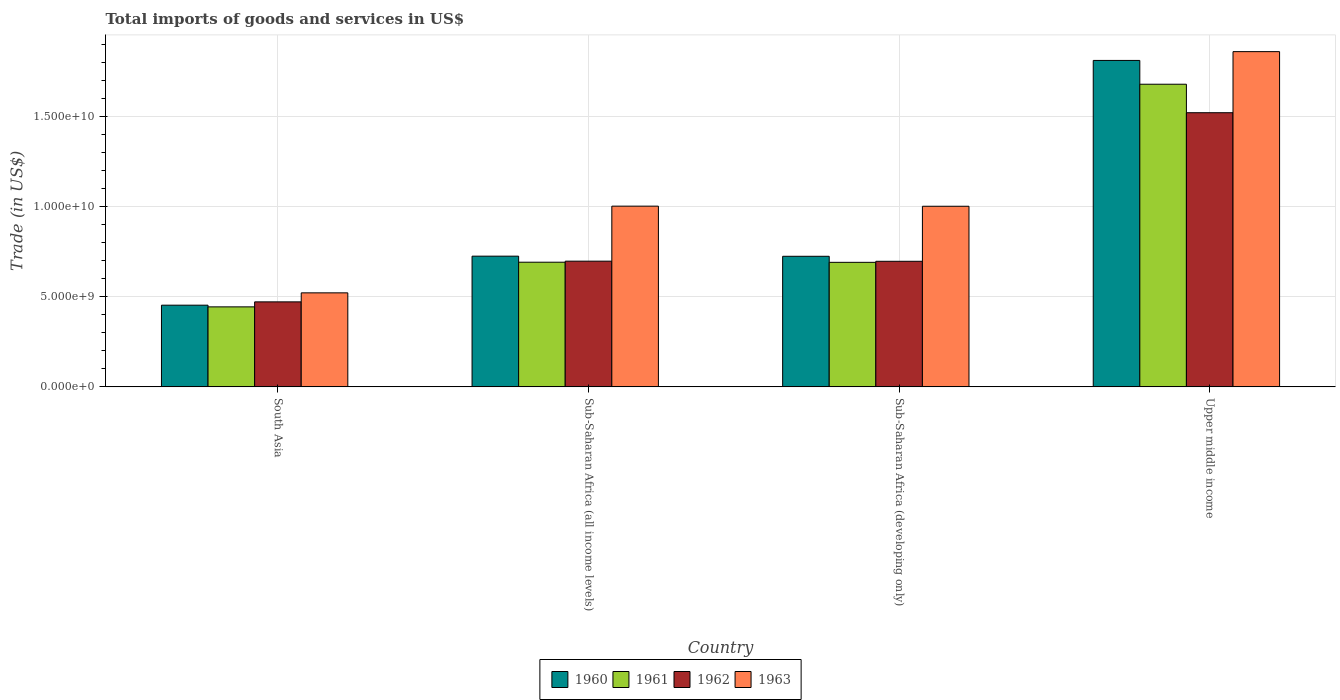How many different coloured bars are there?
Make the answer very short. 4. How many groups of bars are there?
Offer a terse response. 4. How many bars are there on the 4th tick from the left?
Offer a very short reply. 4. What is the label of the 2nd group of bars from the left?
Your response must be concise. Sub-Saharan Africa (all income levels). In how many cases, is the number of bars for a given country not equal to the number of legend labels?
Offer a terse response. 0. What is the total imports of goods and services in 1961 in South Asia?
Offer a very short reply. 4.43e+09. Across all countries, what is the maximum total imports of goods and services in 1962?
Keep it short and to the point. 1.52e+1. Across all countries, what is the minimum total imports of goods and services in 1961?
Your response must be concise. 4.43e+09. In which country was the total imports of goods and services in 1961 maximum?
Make the answer very short. Upper middle income. In which country was the total imports of goods and services in 1961 minimum?
Your answer should be very brief. South Asia. What is the total total imports of goods and services in 1963 in the graph?
Your answer should be compact. 4.38e+1. What is the difference between the total imports of goods and services in 1962 in South Asia and that in Sub-Saharan Africa (all income levels)?
Provide a short and direct response. -2.26e+09. What is the difference between the total imports of goods and services in 1960 in Sub-Saharan Africa (all income levels) and the total imports of goods and services in 1962 in Sub-Saharan Africa (developing only)?
Provide a succinct answer. 2.84e+08. What is the average total imports of goods and services in 1963 per country?
Make the answer very short. 1.10e+1. What is the difference between the total imports of goods and services of/in 1963 and total imports of goods and services of/in 1960 in South Asia?
Offer a terse response. 6.84e+08. What is the ratio of the total imports of goods and services in 1960 in South Asia to that in Upper middle income?
Give a very brief answer. 0.25. Is the difference between the total imports of goods and services in 1963 in South Asia and Sub-Saharan Africa (all income levels) greater than the difference between the total imports of goods and services in 1960 in South Asia and Sub-Saharan Africa (all income levels)?
Your answer should be very brief. No. What is the difference between the highest and the second highest total imports of goods and services in 1962?
Ensure brevity in your answer.  -8.23e+09. What is the difference between the highest and the lowest total imports of goods and services in 1962?
Make the answer very short. 1.05e+1. In how many countries, is the total imports of goods and services in 1963 greater than the average total imports of goods and services in 1963 taken over all countries?
Offer a terse response. 1. Is the sum of the total imports of goods and services in 1960 in Sub-Saharan Africa (all income levels) and Sub-Saharan Africa (developing only) greater than the maximum total imports of goods and services in 1963 across all countries?
Provide a succinct answer. No. Is it the case that in every country, the sum of the total imports of goods and services in 1960 and total imports of goods and services in 1963 is greater than the sum of total imports of goods and services in 1961 and total imports of goods and services in 1962?
Make the answer very short. No. What does the 4th bar from the left in Upper middle income represents?
Make the answer very short. 1963. What does the 2nd bar from the right in Sub-Saharan Africa (developing only) represents?
Offer a terse response. 1962. How many countries are there in the graph?
Your answer should be compact. 4. Are the values on the major ticks of Y-axis written in scientific E-notation?
Make the answer very short. Yes. Where does the legend appear in the graph?
Offer a terse response. Bottom center. How are the legend labels stacked?
Make the answer very short. Horizontal. What is the title of the graph?
Give a very brief answer. Total imports of goods and services in US$. What is the label or title of the X-axis?
Offer a very short reply. Country. What is the label or title of the Y-axis?
Your answer should be compact. Trade (in US$). What is the Trade (in US$) in 1960 in South Asia?
Offer a terse response. 4.53e+09. What is the Trade (in US$) of 1961 in South Asia?
Your answer should be compact. 4.43e+09. What is the Trade (in US$) in 1962 in South Asia?
Provide a short and direct response. 4.71e+09. What is the Trade (in US$) of 1963 in South Asia?
Your answer should be very brief. 5.21e+09. What is the Trade (in US$) of 1960 in Sub-Saharan Africa (all income levels)?
Your answer should be compact. 7.25e+09. What is the Trade (in US$) of 1961 in Sub-Saharan Africa (all income levels)?
Your answer should be compact. 6.91e+09. What is the Trade (in US$) of 1962 in Sub-Saharan Africa (all income levels)?
Make the answer very short. 6.97e+09. What is the Trade (in US$) in 1963 in Sub-Saharan Africa (all income levels)?
Provide a succinct answer. 1.00e+1. What is the Trade (in US$) of 1960 in Sub-Saharan Africa (developing only)?
Provide a short and direct response. 7.24e+09. What is the Trade (in US$) in 1961 in Sub-Saharan Africa (developing only)?
Your answer should be very brief. 6.90e+09. What is the Trade (in US$) of 1962 in Sub-Saharan Africa (developing only)?
Offer a terse response. 6.96e+09. What is the Trade (in US$) in 1963 in Sub-Saharan Africa (developing only)?
Make the answer very short. 1.00e+1. What is the Trade (in US$) of 1960 in Upper middle income?
Provide a succinct answer. 1.81e+1. What is the Trade (in US$) in 1961 in Upper middle income?
Keep it short and to the point. 1.68e+1. What is the Trade (in US$) in 1962 in Upper middle income?
Provide a short and direct response. 1.52e+1. What is the Trade (in US$) in 1963 in Upper middle income?
Offer a terse response. 1.86e+1. Across all countries, what is the maximum Trade (in US$) in 1960?
Your answer should be compact. 1.81e+1. Across all countries, what is the maximum Trade (in US$) in 1961?
Offer a very short reply. 1.68e+1. Across all countries, what is the maximum Trade (in US$) in 1962?
Give a very brief answer. 1.52e+1. Across all countries, what is the maximum Trade (in US$) in 1963?
Keep it short and to the point. 1.86e+1. Across all countries, what is the minimum Trade (in US$) of 1960?
Provide a succinct answer. 4.53e+09. Across all countries, what is the minimum Trade (in US$) in 1961?
Offer a very short reply. 4.43e+09. Across all countries, what is the minimum Trade (in US$) in 1962?
Provide a succinct answer. 4.71e+09. Across all countries, what is the minimum Trade (in US$) in 1963?
Your answer should be compact. 5.21e+09. What is the total Trade (in US$) in 1960 in the graph?
Your answer should be very brief. 3.71e+1. What is the total Trade (in US$) of 1961 in the graph?
Your answer should be very brief. 3.50e+1. What is the total Trade (in US$) of 1962 in the graph?
Your answer should be compact. 3.38e+1. What is the total Trade (in US$) of 1963 in the graph?
Ensure brevity in your answer.  4.38e+1. What is the difference between the Trade (in US$) in 1960 in South Asia and that in Sub-Saharan Africa (all income levels)?
Your answer should be compact. -2.72e+09. What is the difference between the Trade (in US$) in 1961 in South Asia and that in Sub-Saharan Africa (all income levels)?
Keep it short and to the point. -2.47e+09. What is the difference between the Trade (in US$) in 1962 in South Asia and that in Sub-Saharan Africa (all income levels)?
Make the answer very short. -2.26e+09. What is the difference between the Trade (in US$) in 1963 in South Asia and that in Sub-Saharan Africa (all income levels)?
Your response must be concise. -4.81e+09. What is the difference between the Trade (in US$) of 1960 in South Asia and that in Sub-Saharan Africa (developing only)?
Make the answer very short. -2.71e+09. What is the difference between the Trade (in US$) in 1961 in South Asia and that in Sub-Saharan Africa (developing only)?
Your answer should be very brief. -2.47e+09. What is the difference between the Trade (in US$) of 1962 in South Asia and that in Sub-Saharan Africa (developing only)?
Your answer should be compact. -2.25e+09. What is the difference between the Trade (in US$) of 1963 in South Asia and that in Sub-Saharan Africa (developing only)?
Your response must be concise. -4.80e+09. What is the difference between the Trade (in US$) in 1960 in South Asia and that in Upper middle income?
Ensure brevity in your answer.  -1.36e+1. What is the difference between the Trade (in US$) of 1961 in South Asia and that in Upper middle income?
Your answer should be very brief. -1.23e+1. What is the difference between the Trade (in US$) of 1962 in South Asia and that in Upper middle income?
Give a very brief answer. -1.05e+1. What is the difference between the Trade (in US$) of 1963 in South Asia and that in Upper middle income?
Give a very brief answer. -1.34e+1. What is the difference between the Trade (in US$) of 1960 in Sub-Saharan Africa (all income levels) and that in Sub-Saharan Africa (developing only)?
Give a very brief answer. 6.98e+06. What is the difference between the Trade (in US$) in 1961 in Sub-Saharan Africa (all income levels) and that in Sub-Saharan Africa (developing only)?
Give a very brief answer. 6.66e+06. What is the difference between the Trade (in US$) in 1962 in Sub-Saharan Africa (all income levels) and that in Sub-Saharan Africa (developing only)?
Make the answer very short. 6.72e+06. What is the difference between the Trade (in US$) in 1963 in Sub-Saharan Africa (all income levels) and that in Sub-Saharan Africa (developing only)?
Provide a succinct answer. 5.66e+06. What is the difference between the Trade (in US$) of 1960 in Sub-Saharan Africa (all income levels) and that in Upper middle income?
Give a very brief answer. -1.08e+1. What is the difference between the Trade (in US$) of 1961 in Sub-Saharan Africa (all income levels) and that in Upper middle income?
Make the answer very short. -9.87e+09. What is the difference between the Trade (in US$) of 1962 in Sub-Saharan Africa (all income levels) and that in Upper middle income?
Ensure brevity in your answer.  -8.23e+09. What is the difference between the Trade (in US$) in 1963 in Sub-Saharan Africa (all income levels) and that in Upper middle income?
Ensure brevity in your answer.  -8.56e+09. What is the difference between the Trade (in US$) in 1960 in Sub-Saharan Africa (developing only) and that in Upper middle income?
Make the answer very short. -1.09e+1. What is the difference between the Trade (in US$) of 1961 in Sub-Saharan Africa (developing only) and that in Upper middle income?
Your answer should be very brief. -9.87e+09. What is the difference between the Trade (in US$) of 1962 in Sub-Saharan Africa (developing only) and that in Upper middle income?
Your response must be concise. -8.24e+09. What is the difference between the Trade (in US$) of 1963 in Sub-Saharan Africa (developing only) and that in Upper middle income?
Your answer should be very brief. -8.57e+09. What is the difference between the Trade (in US$) in 1960 in South Asia and the Trade (in US$) in 1961 in Sub-Saharan Africa (all income levels)?
Your answer should be very brief. -2.38e+09. What is the difference between the Trade (in US$) of 1960 in South Asia and the Trade (in US$) of 1962 in Sub-Saharan Africa (all income levels)?
Provide a short and direct response. -2.44e+09. What is the difference between the Trade (in US$) in 1960 in South Asia and the Trade (in US$) in 1963 in Sub-Saharan Africa (all income levels)?
Provide a succinct answer. -5.49e+09. What is the difference between the Trade (in US$) in 1961 in South Asia and the Trade (in US$) in 1962 in Sub-Saharan Africa (all income levels)?
Ensure brevity in your answer.  -2.53e+09. What is the difference between the Trade (in US$) in 1961 in South Asia and the Trade (in US$) in 1963 in Sub-Saharan Africa (all income levels)?
Keep it short and to the point. -5.58e+09. What is the difference between the Trade (in US$) in 1962 in South Asia and the Trade (in US$) in 1963 in Sub-Saharan Africa (all income levels)?
Ensure brevity in your answer.  -5.31e+09. What is the difference between the Trade (in US$) of 1960 in South Asia and the Trade (in US$) of 1961 in Sub-Saharan Africa (developing only)?
Ensure brevity in your answer.  -2.38e+09. What is the difference between the Trade (in US$) in 1960 in South Asia and the Trade (in US$) in 1962 in Sub-Saharan Africa (developing only)?
Keep it short and to the point. -2.43e+09. What is the difference between the Trade (in US$) in 1960 in South Asia and the Trade (in US$) in 1963 in Sub-Saharan Africa (developing only)?
Your response must be concise. -5.48e+09. What is the difference between the Trade (in US$) in 1961 in South Asia and the Trade (in US$) in 1962 in Sub-Saharan Africa (developing only)?
Make the answer very short. -2.53e+09. What is the difference between the Trade (in US$) in 1961 in South Asia and the Trade (in US$) in 1963 in Sub-Saharan Africa (developing only)?
Offer a terse response. -5.58e+09. What is the difference between the Trade (in US$) in 1962 in South Asia and the Trade (in US$) in 1963 in Sub-Saharan Africa (developing only)?
Your answer should be compact. -5.30e+09. What is the difference between the Trade (in US$) of 1960 in South Asia and the Trade (in US$) of 1961 in Upper middle income?
Your response must be concise. -1.22e+1. What is the difference between the Trade (in US$) in 1960 in South Asia and the Trade (in US$) in 1962 in Upper middle income?
Ensure brevity in your answer.  -1.07e+1. What is the difference between the Trade (in US$) of 1960 in South Asia and the Trade (in US$) of 1963 in Upper middle income?
Give a very brief answer. -1.41e+1. What is the difference between the Trade (in US$) in 1961 in South Asia and the Trade (in US$) in 1962 in Upper middle income?
Your response must be concise. -1.08e+1. What is the difference between the Trade (in US$) in 1961 in South Asia and the Trade (in US$) in 1963 in Upper middle income?
Your answer should be compact. -1.41e+1. What is the difference between the Trade (in US$) in 1962 in South Asia and the Trade (in US$) in 1963 in Upper middle income?
Your response must be concise. -1.39e+1. What is the difference between the Trade (in US$) of 1960 in Sub-Saharan Africa (all income levels) and the Trade (in US$) of 1961 in Sub-Saharan Africa (developing only)?
Your response must be concise. 3.42e+08. What is the difference between the Trade (in US$) of 1960 in Sub-Saharan Africa (all income levels) and the Trade (in US$) of 1962 in Sub-Saharan Africa (developing only)?
Provide a short and direct response. 2.84e+08. What is the difference between the Trade (in US$) of 1960 in Sub-Saharan Africa (all income levels) and the Trade (in US$) of 1963 in Sub-Saharan Africa (developing only)?
Provide a succinct answer. -2.77e+09. What is the difference between the Trade (in US$) of 1961 in Sub-Saharan Africa (all income levels) and the Trade (in US$) of 1962 in Sub-Saharan Africa (developing only)?
Keep it short and to the point. -5.13e+07. What is the difference between the Trade (in US$) in 1961 in Sub-Saharan Africa (all income levels) and the Trade (in US$) in 1963 in Sub-Saharan Africa (developing only)?
Ensure brevity in your answer.  -3.10e+09. What is the difference between the Trade (in US$) in 1962 in Sub-Saharan Africa (all income levels) and the Trade (in US$) in 1963 in Sub-Saharan Africa (developing only)?
Offer a very short reply. -3.04e+09. What is the difference between the Trade (in US$) of 1960 in Sub-Saharan Africa (all income levels) and the Trade (in US$) of 1961 in Upper middle income?
Offer a very short reply. -9.53e+09. What is the difference between the Trade (in US$) of 1960 in Sub-Saharan Africa (all income levels) and the Trade (in US$) of 1962 in Upper middle income?
Give a very brief answer. -7.95e+09. What is the difference between the Trade (in US$) of 1960 in Sub-Saharan Africa (all income levels) and the Trade (in US$) of 1963 in Upper middle income?
Provide a short and direct response. -1.13e+1. What is the difference between the Trade (in US$) in 1961 in Sub-Saharan Africa (all income levels) and the Trade (in US$) in 1962 in Upper middle income?
Your answer should be compact. -8.29e+09. What is the difference between the Trade (in US$) of 1961 in Sub-Saharan Africa (all income levels) and the Trade (in US$) of 1963 in Upper middle income?
Offer a terse response. -1.17e+1. What is the difference between the Trade (in US$) of 1962 in Sub-Saharan Africa (all income levels) and the Trade (in US$) of 1963 in Upper middle income?
Ensure brevity in your answer.  -1.16e+1. What is the difference between the Trade (in US$) of 1960 in Sub-Saharan Africa (developing only) and the Trade (in US$) of 1961 in Upper middle income?
Offer a terse response. -9.54e+09. What is the difference between the Trade (in US$) in 1960 in Sub-Saharan Africa (developing only) and the Trade (in US$) in 1962 in Upper middle income?
Offer a very short reply. -7.96e+09. What is the difference between the Trade (in US$) in 1960 in Sub-Saharan Africa (developing only) and the Trade (in US$) in 1963 in Upper middle income?
Provide a succinct answer. -1.13e+1. What is the difference between the Trade (in US$) of 1961 in Sub-Saharan Africa (developing only) and the Trade (in US$) of 1962 in Upper middle income?
Make the answer very short. -8.29e+09. What is the difference between the Trade (in US$) in 1961 in Sub-Saharan Africa (developing only) and the Trade (in US$) in 1963 in Upper middle income?
Your answer should be very brief. -1.17e+1. What is the difference between the Trade (in US$) in 1962 in Sub-Saharan Africa (developing only) and the Trade (in US$) in 1963 in Upper middle income?
Offer a very short reply. -1.16e+1. What is the average Trade (in US$) of 1960 per country?
Ensure brevity in your answer.  9.28e+09. What is the average Trade (in US$) of 1961 per country?
Your answer should be very brief. 8.76e+09. What is the average Trade (in US$) of 1962 per country?
Your response must be concise. 8.46e+09. What is the average Trade (in US$) of 1963 per country?
Provide a short and direct response. 1.10e+1. What is the difference between the Trade (in US$) in 1960 and Trade (in US$) in 1961 in South Asia?
Provide a short and direct response. 9.31e+07. What is the difference between the Trade (in US$) in 1960 and Trade (in US$) in 1962 in South Asia?
Ensure brevity in your answer.  -1.84e+08. What is the difference between the Trade (in US$) in 1960 and Trade (in US$) in 1963 in South Asia?
Your answer should be very brief. -6.84e+08. What is the difference between the Trade (in US$) in 1961 and Trade (in US$) in 1962 in South Asia?
Offer a very short reply. -2.77e+08. What is the difference between the Trade (in US$) in 1961 and Trade (in US$) in 1963 in South Asia?
Make the answer very short. -7.77e+08. What is the difference between the Trade (in US$) in 1962 and Trade (in US$) in 1963 in South Asia?
Make the answer very short. -5.00e+08. What is the difference between the Trade (in US$) of 1960 and Trade (in US$) of 1961 in Sub-Saharan Africa (all income levels)?
Give a very brief answer. 3.36e+08. What is the difference between the Trade (in US$) of 1960 and Trade (in US$) of 1962 in Sub-Saharan Africa (all income levels)?
Your response must be concise. 2.78e+08. What is the difference between the Trade (in US$) of 1960 and Trade (in US$) of 1963 in Sub-Saharan Africa (all income levels)?
Your answer should be very brief. -2.77e+09. What is the difference between the Trade (in US$) of 1961 and Trade (in US$) of 1962 in Sub-Saharan Africa (all income levels)?
Give a very brief answer. -5.80e+07. What is the difference between the Trade (in US$) in 1961 and Trade (in US$) in 1963 in Sub-Saharan Africa (all income levels)?
Offer a terse response. -3.11e+09. What is the difference between the Trade (in US$) of 1962 and Trade (in US$) of 1963 in Sub-Saharan Africa (all income levels)?
Your response must be concise. -3.05e+09. What is the difference between the Trade (in US$) of 1960 and Trade (in US$) of 1961 in Sub-Saharan Africa (developing only)?
Give a very brief answer. 3.35e+08. What is the difference between the Trade (in US$) of 1960 and Trade (in US$) of 1962 in Sub-Saharan Africa (developing only)?
Offer a very short reply. 2.77e+08. What is the difference between the Trade (in US$) of 1960 and Trade (in US$) of 1963 in Sub-Saharan Africa (developing only)?
Your response must be concise. -2.77e+09. What is the difference between the Trade (in US$) in 1961 and Trade (in US$) in 1962 in Sub-Saharan Africa (developing only)?
Make the answer very short. -5.79e+07. What is the difference between the Trade (in US$) of 1961 and Trade (in US$) of 1963 in Sub-Saharan Africa (developing only)?
Give a very brief answer. -3.11e+09. What is the difference between the Trade (in US$) of 1962 and Trade (in US$) of 1963 in Sub-Saharan Africa (developing only)?
Your answer should be very brief. -3.05e+09. What is the difference between the Trade (in US$) of 1960 and Trade (in US$) of 1961 in Upper middle income?
Keep it short and to the point. 1.32e+09. What is the difference between the Trade (in US$) in 1960 and Trade (in US$) in 1962 in Upper middle income?
Your answer should be very brief. 2.90e+09. What is the difference between the Trade (in US$) in 1960 and Trade (in US$) in 1963 in Upper middle income?
Keep it short and to the point. -4.87e+08. What is the difference between the Trade (in US$) of 1961 and Trade (in US$) of 1962 in Upper middle income?
Offer a very short reply. 1.58e+09. What is the difference between the Trade (in US$) of 1961 and Trade (in US$) of 1963 in Upper middle income?
Offer a terse response. -1.81e+09. What is the difference between the Trade (in US$) of 1962 and Trade (in US$) of 1963 in Upper middle income?
Offer a terse response. -3.39e+09. What is the ratio of the Trade (in US$) of 1960 in South Asia to that in Sub-Saharan Africa (all income levels)?
Give a very brief answer. 0.62. What is the ratio of the Trade (in US$) in 1961 in South Asia to that in Sub-Saharan Africa (all income levels)?
Your response must be concise. 0.64. What is the ratio of the Trade (in US$) of 1962 in South Asia to that in Sub-Saharan Africa (all income levels)?
Your answer should be very brief. 0.68. What is the ratio of the Trade (in US$) of 1963 in South Asia to that in Sub-Saharan Africa (all income levels)?
Provide a short and direct response. 0.52. What is the ratio of the Trade (in US$) in 1960 in South Asia to that in Sub-Saharan Africa (developing only)?
Make the answer very short. 0.63. What is the ratio of the Trade (in US$) in 1961 in South Asia to that in Sub-Saharan Africa (developing only)?
Offer a terse response. 0.64. What is the ratio of the Trade (in US$) in 1962 in South Asia to that in Sub-Saharan Africa (developing only)?
Provide a short and direct response. 0.68. What is the ratio of the Trade (in US$) of 1963 in South Asia to that in Sub-Saharan Africa (developing only)?
Provide a succinct answer. 0.52. What is the ratio of the Trade (in US$) in 1960 in South Asia to that in Upper middle income?
Your answer should be very brief. 0.25. What is the ratio of the Trade (in US$) in 1961 in South Asia to that in Upper middle income?
Provide a succinct answer. 0.26. What is the ratio of the Trade (in US$) in 1962 in South Asia to that in Upper middle income?
Make the answer very short. 0.31. What is the ratio of the Trade (in US$) of 1963 in South Asia to that in Upper middle income?
Provide a succinct answer. 0.28. What is the ratio of the Trade (in US$) in 1962 in Sub-Saharan Africa (all income levels) to that in Sub-Saharan Africa (developing only)?
Make the answer very short. 1. What is the ratio of the Trade (in US$) in 1960 in Sub-Saharan Africa (all income levels) to that in Upper middle income?
Offer a terse response. 0.4. What is the ratio of the Trade (in US$) in 1961 in Sub-Saharan Africa (all income levels) to that in Upper middle income?
Provide a short and direct response. 0.41. What is the ratio of the Trade (in US$) of 1962 in Sub-Saharan Africa (all income levels) to that in Upper middle income?
Keep it short and to the point. 0.46. What is the ratio of the Trade (in US$) in 1963 in Sub-Saharan Africa (all income levels) to that in Upper middle income?
Provide a succinct answer. 0.54. What is the ratio of the Trade (in US$) of 1960 in Sub-Saharan Africa (developing only) to that in Upper middle income?
Your response must be concise. 0.4. What is the ratio of the Trade (in US$) in 1961 in Sub-Saharan Africa (developing only) to that in Upper middle income?
Make the answer very short. 0.41. What is the ratio of the Trade (in US$) in 1962 in Sub-Saharan Africa (developing only) to that in Upper middle income?
Keep it short and to the point. 0.46. What is the ratio of the Trade (in US$) in 1963 in Sub-Saharan Africa (developing only) to that in Upper middle income?
Your response must be concise. 0.54. What is the difference between the highest and the second highest Trade (in US$) in 1960?
Your answer should be very brief. 1.08e+1. What is the difference between the highest and the second highest Trade (in US$) of 1961?
Provide a short and direct response. 9.87e+09. What is the difference between the highest and the second highest Trade (in US$) in 1962?
Keep it short and to the point. 8.23e+09. What is the difference between the highest and the second highest Trade (in US$) of 1963?
Give a very brief answer. 8.56e+09. What is the difference between the highest and the lowest Trade (in US$) of 1960?
Give a very brief answer. 1.36e+1. What is the difference between the highest and the lowest Trade (in US$) in 1961?
Give a very brief answer. 1.23e+1. What is the difference between the highest and the lowest Trade (in US$) in 1962?
Ensure brevity in your answer.  1.05e+1. What is the difference between the highest and the lowest Trade (in US$) in 1963?
Your answer should be compact. 1.34e+1. 